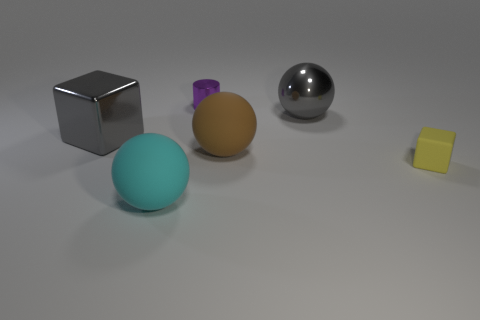What size is the gray cube that is the same material as the purple cylinder?
Your response must be concise. Large. What color is the thing that is both left of the tiny purple metallic thing and to the right of the large gray metallic cube?
Give a very brief answer. Cyan. How many blocks are the same size as the gray ball?
Your response must be concise. 1. What size is the metallic sphere that is the same color as the big shiny cube?
Provide a succinct answer. Large. What is the size of the metallic object that is both on the right side of the large gray shiny block and to the left of the big metallic ball?
Provide a succinct answer. Small. There is a object right of the big gray metallic thing on the right side of the tiny shiny thing; how many things are in front of it?
Your response must be concise. 1. Are there any small matte cylinders of the same color as the shiny sphere?
Provide a short and direct response. No. There is a metal ball that is the same size as the gray cube; what is its color?
Your answer should be compact. Gray. There is a gray shiny object that is on the left side of the large matte ball that is behind the sphere left of the big brown ball; what shape is it?
Ensure brevity in your answer.  Cube. What number of brown balls are behind the large shiny object that is right of the brown ball?
Make the answer very short. 0. 